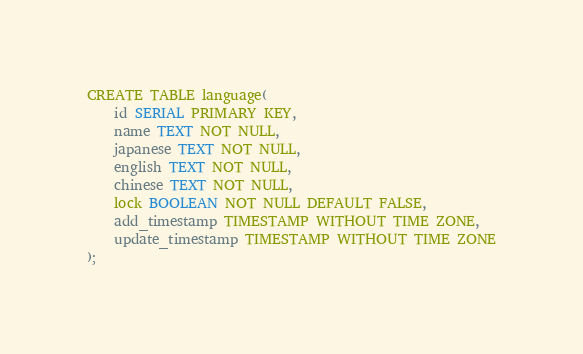<code> <loc_0><loc_0><loc_500><loc_500><_SQL_>CREATE TABLE language(
    id SERIAL PRIMARY KEY,
    name TEXT NOT NULL,
    japanese TEXT NOT NULL,
    english TEXT NOT NULL,
    chinese TEXT NOT NULL,
    lock BOOLEAN NOT NULL DEFAULT FALSE,
    add_timestamp TIMESTAMP WITHOUT TIME ZONE,
    update_timestamp TIMESTAMP WITHOUT TIME ZONE
);</code> 